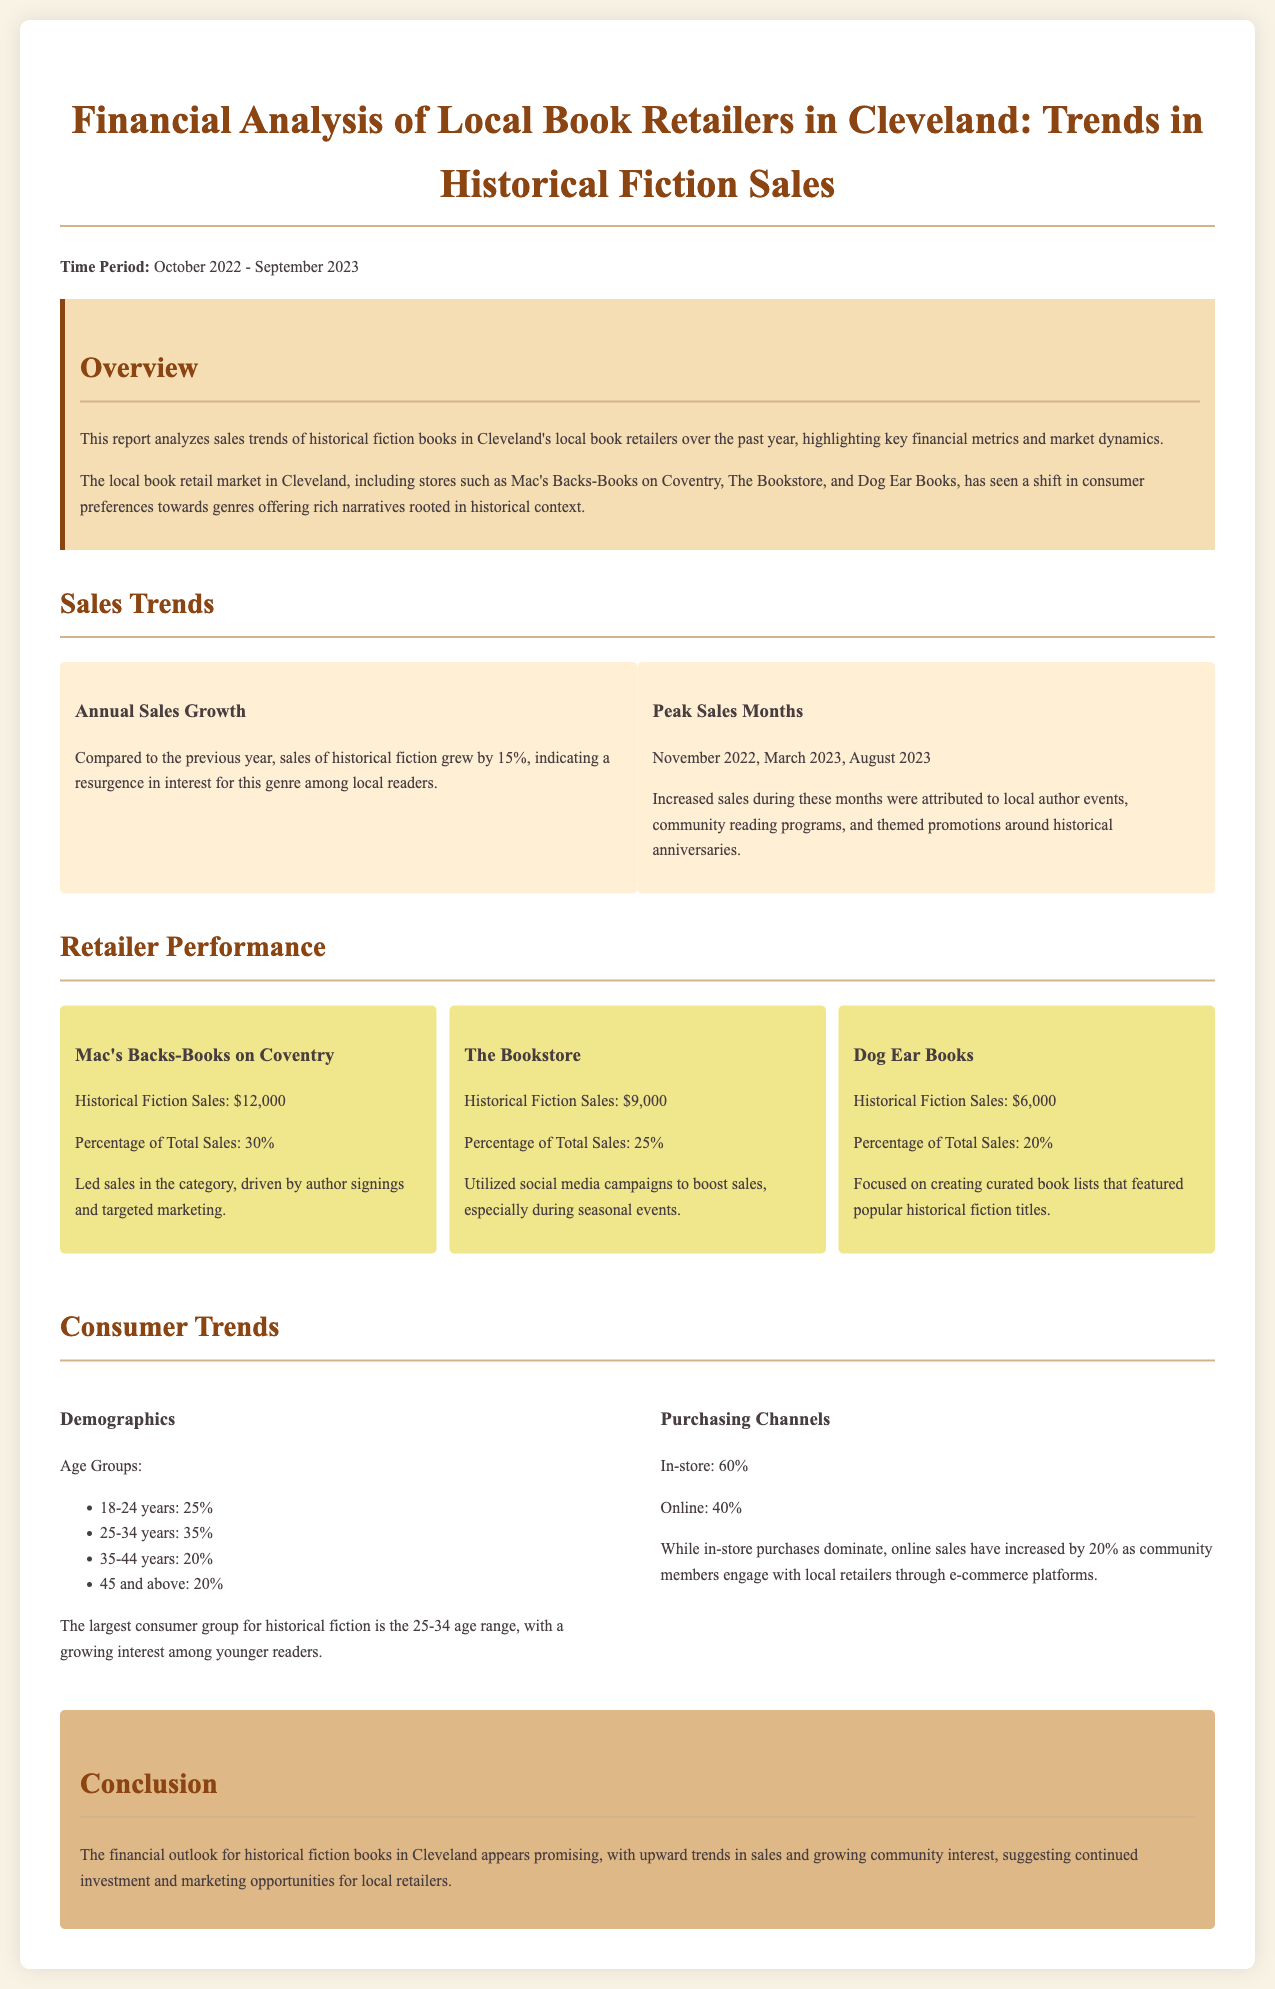What was the annual sales growth for historical fiction? The document states that sales of historical fiction grew by 15% compared to the previous year.
Answer: 15% Which retailer led sales in historical fiction? The document mentions that Mac's Backs-Books on Coventry led sales in the category.
Answer: Mac's Backs-Books on Coventry What was the historical fiction sales figure for The Bookstore? According to the report, The Bookstore had historical fiction sales of $9,000.
Answer: $9,000 During which month did sales peak in August 2023? The document indicates that there was increased sales in August 2023, alongside November 2022 and March 2023.
Answer: August 2023 What percentage of total sales did Dog Ear Books generate from historical fiction? The report states that Dog Ear Books accounted for 20% of total sales from historical fiction.
Answer: 20% Which age group constitutes the largest consumer group for historical fiction? The document indicates that the largest consumer group for historical fiction is in the 25-34 age range.
Answer: 25-34 years What was the increase in online sales for historical fiction? The report specifies that online sales have increased by 20%.
Answer: 20% What is the primary purchasing channel for historical fiction? According to the data, in-store purchases dominate at 60%.
Answer: 60% 